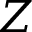Convert formula to latex. <formula><loc_0><loc_0><loc_500><loc_500>Z</formula> 